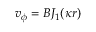<formula> <loc_0><loc_0><loc_500><loc_500>v _ { \phi } = B J _ { 1 } ( \kappa r )</formula> 